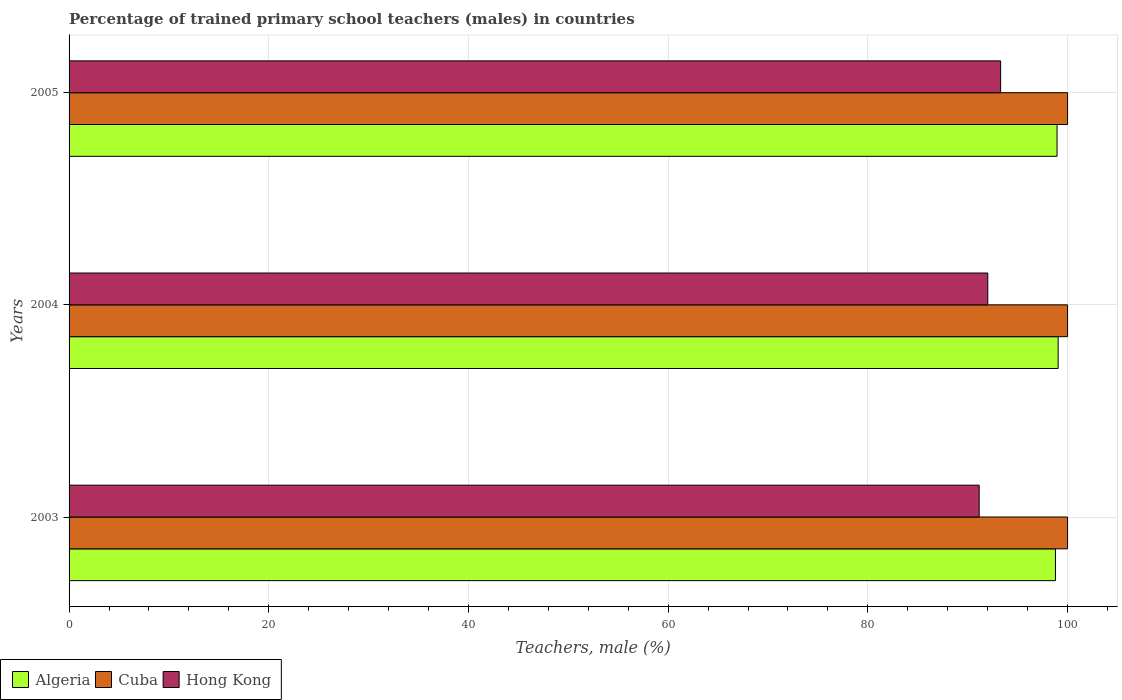How many groups of bars are there?
Provide a succinct answer. 3. Are the number of bars per tick equal to the number of legend labels?
Offer a very short reply. Yes. Are the number of bars on each tick of the Y-axis equal?
Offer a very short reply. Yes. How many bars are there on the 1st tick from the top?
Give a very brief answer. 3. How many bars are there on the 3rd tick from the bottom?
Ensure brevity in your answer.  3. What is the label of the 2nd group of bars from the top?
Your answer should be compact. 2004. What is the percentage of trained primary school teachers (males) in Algeria in 2003?
Your response must be concise. 98.79. Across all years, what is the maximum percentage of trained primary school teachers (males) in Algeria?
Provide a short and direct response. 99.06. Across all years, what is the minimum percentage of trained primary school teachers (males) in Algeria?
Keep it short and to the point. 98.79. In which year was the percentage of trained primary school teachers (males) in Hong Kong maximum?
Offer a very short reply. 2005. What is the total percentage of trained primary school teachers (males) in Cuba in the graph?
Make the answer very short. 300. What is the difference between the percentage of trained primary school teachers (males) in Hong Kong in 2003 and that in 2005?
Your answer should be very brief. -2.15. What is the difference between the percentage of trained primary school teachers (males) in Hong Kong in 2005 and the percentage of trained primary school teachers (males) in Cuba in 2003?
Offer a very short reply. -6.7. What is the average percentage of trained primary school teachers (males) in Hong Kong per year?
Offer a terse response. 92.15. In the year 2005, what is the difference between the percentage of trained primary school teachers (males) in Algeria and percentage of trained primary school teachers (males) in Cuba?
Provide a short and direct response. -1.05. In how many years, is the percentage of trained primary school teachers (males) in Cuba greater than 20 %?
Your response must be concise. 3. What is the ratio of the percentage of trained primary school teachers (males) in Hong Kong in 2003 to that in 2004?
Offer a very short reply. 0.99. What is the difference between the highest and the second highest percentage of trained primary school teachers (males) in Hong Kong?
Ensure brevity in your answer.  1.29. What is the difference between the highest and the lowest percentage of trained primary school teachers (males) in Hong Kong?
Ensure brevity in your answer.  2.15. Is the sum of the percentage of trained primary school teachers (males) in Algeria in 2003 and 2004 greater than the maximum percentage of trained primary school teachers (males) in Cuba across all years?
Your answer should be very brief. Yes. What does the 1st bar from the top in 2003 represents?
Your answer should be compact. Hong Kong. What does the 3rd bar from the bottom in 2003 represents?
Keep it short and to the point. Hong Kong. Is it the case that in every year, the sum of the percentage of trained primary school teachers (males) in Hong Kong and percentage of trained primary school teachers (males) in Algeria is greater than the percentage of trained primary school teachers (males) in Cuba?
Your answer should be compact. Yes. How many bars are there?
Offer a very short reply. 9. Are all the bars in the graph horizontal?
Make the answer very short. Yes. How many years are there in the graph?
Give a very brief answer. 3. Are the values on the major ticks of X-axis written in scientific E-notation?
Keep it short and to the point. No. What is the title of the graph?
Ensure brevity in your answer.  Percentage of trained primary school teachers (males) in countries. What is the label or title of the X-axis?
Your response must be concise. Teachers, male (%). What is the label or title of the Y-axis?
Offer a terse response. Years. What is the Teachers, male (%) of Algeria in 2003?
Your response must be concise. 98.79. What is the Teachers, male (%) in Cuba in 2003?
Keep it short and to the point. 100. What is the Teachers, male (%) in Hong Kong in 2003?
Ensure brevity in your answer.  91.15. What is the Teachers, male (%) of Algeria in 2004?
Your answer should be compact. 99.06. What is the Teachers, male (%) of Cuba in 2004?
Provide a succinct answer. 100. What is the Teachers, male (%) in Hong Kong in 2004?
Ensure brevity in your answer.  92.01. What is the Teachers, male (%) of Algeria in 2005?
Your answer should be compact. 98.95. What is the Teachers, male (%) in Cuba in 2005?
Give a very brief answer. 100. What is the Teachers, male (%) in Hong Kong in 2005?
Offer a very short reply. 93.3. Across all years, what is the maximum Teachers, male (%) in Algeria?
Your answer should be compact. 99.06. Across all years, what is the maximum Teachers, male (%) in Hong Kong?
Offer a terse response. 93.3. Across all years, what is the minimum Teachers, male (%) in Algeria?
Provide a short and direct response. 98.79. Across all years, what is the minimum Teachers, male (%) in Hong Kong?
Your response must be concise. 91.15. What is the total Teachers, male (%) of Algeria in the graph?
Your answer should be very brief. 296.8. What is the total Teachers, male (%) of Cuba in the graph?
Provide a short and direct response. 300. What is the total Teachers, male (%) in Hong Kong in the graph?
Provide a short and direct response. 276.45. What is the difference between the Teachers, male (%) in Algeria in 2003 and that in 2004?
Your answer should be compact. -0.27. What is the difference between the Teachers, male (%) of Cuba in 2003 and that in 2004?
Ensure brevity in your answer.  0. What is the difference between the Teachers, male (%) in Hong Kong in 2003 and that in 2004?
Provide a short and direct response. -0.86. What is the difference between the Teachers, male (%) of Algeria in 2003 and that in 2005?
Provide a succinct answer. -0.16. What is the difference between the Teachers, male (%) of Cuba in 2003 and that in 2005?
Keep it short and to the point. 0. What is the difference between the Teachers, male (%) of Hong Kong in 2003 and that in 2005?
Make the answer very short. -2.15. What is the difference between the Teachers, male (%) in Algeria in 2004 and that in 2005?
Offer a terse response. 0.11. What is the difference between the Teachers, male (%) of Cuba in 2004 and that in 2005?
Provide a succinct answer. 0. What is the difference between the Teachers, male (%) of Hong Kong in 2004 and that in 2005?
Offer a terse response. -1.29. What is the difference between the Teachers, male (%) of Algeria in 2003 and the Teachers, male (%) of Cuba in 2004?
Give a very brief answer. -1.21. What is the difference between the Teachers, male (%) of Algeria in 2003 and the Teachers, male (%) of Hong Kong in 2004?
Ensure brevity in your answer.  6.78. What is the difference between the Teachers, male (%) in Cuba in 2003 and the Teachers, male (%) in Hong Kong in 2004?
Provide a short and direct response. 7.99. What is the difference between the Teachers, male (%) of Algeria in 2003 and the Teachers, male (%) of Cuba in 2005?
Give a very brief answer. -1.21. What is the difference between the Teachers, male (%) of Algeria in 2003 and the Teachers, male (%) of Hong Kong in 2005?
Make the answer very short. 5.49. What is the difference between the Teachers, male (%) in Cuba in 2003 and the Teachers, male (%) in Hong Kong in 2005?
Ensure brevity in your answer.  6.7. What is the difference between the Teachers, male (%) in Algeria in 2004 and the Teachers, male (%) in Cuba in 2005?
Your response must be concise. -0.94. What is the difference between the Teachers, male (%) of Algeria in 2004 and the Teachers, male (%) of Hong Kong in 2005?
Give a very brief answer. 5.76. What is the difference between the Teachers, male (%) of Cuba in 2004 and the Teachers, male (%) of Hong Kong in 2005?
Offer a terse response. 6.7. What is the average Teachers, male (%) of Algeria per year?
Provide a short and direct response. 98.93. What is the average Teachers, male (%) in Cuba per year?
Offer a very short reply. 100. What is the average Teachers, male (%) in Hong Kong per year?
Your answer should be compact. 92.15. In the year 2003, what is the difference between the Teachers, male (%) of Algeria and Teachers, male (%) of Cuba?
Offer a terse response. -1.21. In the year 2003, what is the difference between the Teachers, male (%) in Algeria and Teachers, male (%) in Hong Kong?
Keep it short and to the point. 7.64. In the year 2003, what is the difference between the Teachers, male (%) of Cuba and Teachers, male (%) of Hong Kong?
Keep it short and to the point. 8.85. In the year 2004, what is the difference between the Teachers, male (%) of Algeria and Teachers, male (%) of Cuba?
Offer a terse response. -0.94. In the year 2004, what is the difference between the Teachers, male (%) in Algeria and Teachers, male (%) in Hong Kong?
Offer a very short reply. 7.05. In the year 2004, what is the difference between the Teachers, male (%) of Cuba and Teachers, male (%) of Hong Kong?
Give a very brief answer. 7.99. In the year 2005, what is the difference between the Teachers, male (%) in Algeria and Teachers, male (%) in Cuba?
Offer a very short reply. -1.05. In the year 2005, what is the difference between the Teachers, male (%) in Algeria and Teachers, male (%) in Hong Kong?
Offer a very short reply. 5.65. In the year 2005, what is the difference between the Teachers, male (%) in Cuba and Teachers, male (%) in Hong Kong?
Offer a very short reply. 6.7. What is the ratio of the Teachers, male (%) of Algeria in 2003 to that in 2004?
Keep it short and to the point. 1. What is the ratio of the Teachers, male (%) of Cuba in 2003 to that in 2004?
Make the answer very short. 1. What is the ratio of the Teachers, male (%) in Hong Kong in 2003 to that in 2004?
Keep it short and to the point. 0.99. What is the ratio of the Teachers, male (%) in Cuba in 2004 to that in 2005?
Your response must be concise. 1. What is the ratio of the Teachers, male (%) in Hong Kong in 2004 to that in 2005?
Ensure brevity in your answer.  0.99. What is the difference between the highest and the second highest Teachers, male (%) of Algeria?
Give a very brief answer. 0.11. What is the difference between the highest and the second highest Teachers, male (%) of Cuba?
Keep it short and to the point. 0. What is the difference between the highest and the second highest Teachers, male (%) of Hong Kong?
Your answer should be very brief. 1.29. What is the difference between the highest and the lowest Teachers, male (%) of Algeria?
Your response must be concise. 0.27. What is the difference between the highest and the lowest Teachers, male (%) in Cuba?
Offer a terse response. 0. What is the difference between the highest and the lowest Teachers, male (%) of Hong Kong?
Provide a short and direct response. 2.15. 